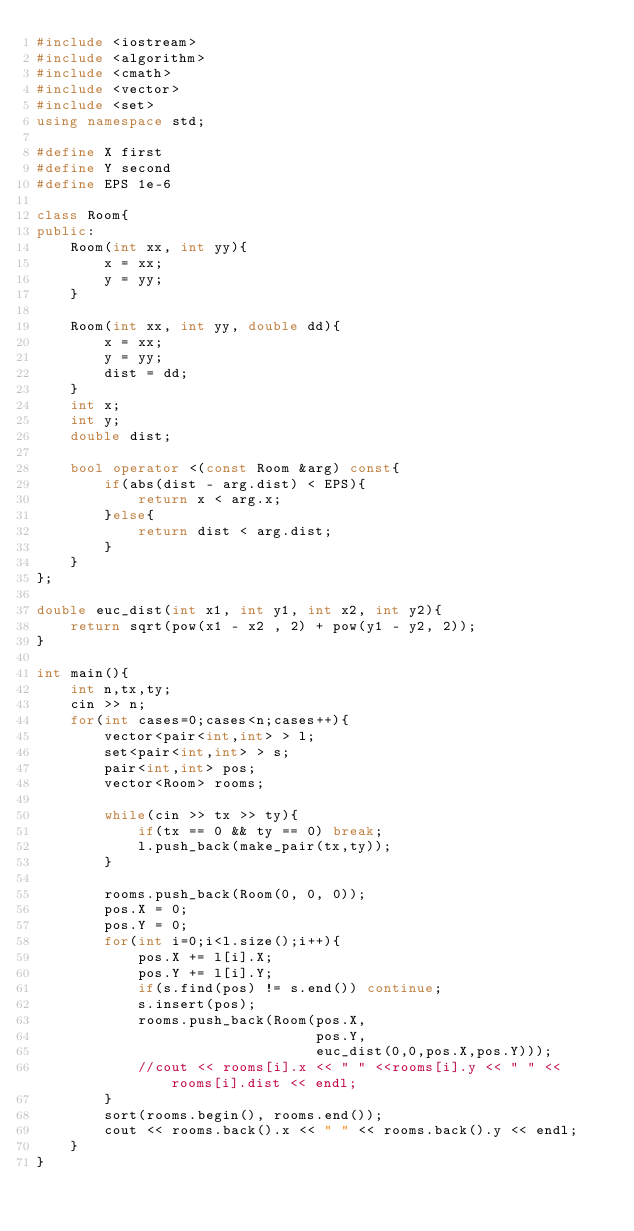Convert code to text. <code><loc_0><loc_0><loc_500><loc_500><_C++_>#include <iostream>
#include <algorithm>
#include <cmath>
#include <vector>
#include <set>
using namespace std;

#define X first
#define Y second
#define EPS 1e-6

class Room{
public:
	Room(int xx, int yy){
		x = xx;
		y = yy;
	}

	Room(int xx, int yy, double dd){
		x = xx;
		y = yy;
		dist = dd;
	}
	int x;
	int y;
	double dist;
	
	bool operator <(const Room &arg) const{
		if(abs(dist - arg.dist) < EPS){
			return x < arg.x;
		}else{
			return dist < arg.dist;
		}
	}
};

double euc_dist(int x1, int y1, int x2, int y2){
	return sqrt(pow(x1 - x2 , 2) + pow(y1 - y2, 2));
}

int main(){
	int n,tx,ty;
	cin >> n;
	for(int cases=0;cases<n;cases++){
		vector<pair<int,int> > l;
		set<pair<int,int> > s;
		pair<int,int> pos;
		vector<Room> rooms;
		
		while(cin >> tx >> ty){
			if(tx == 0 && ty == 0) break;
			l.push_back(make_pair(tx,ty));
		}

		rooms.push_back(Room(0, 0, 0));
		pos.X = 0;
		pos.Y = 0;
		for(int i=0;i<l.size();i++){
			pos.X += l[i].X;
			pos.Y += l[i].Y;
			if(s.find(pos) != s.end()) continue;
			s.insert(pos);
			rooms.push_back(Room(pos.X,
								 pos.Y,
								 euc_dist(0,0,pos.X,pos.Y)));
			//cout << rooms[i].x << " " <<rooms[i].y << " " << rooms[i].dist << endl;
		}
		sort(rooms.begin(), rooms.end());
		cout << rooms.back().x << " " << rooms.back().y << endl;
	}
}</code> 